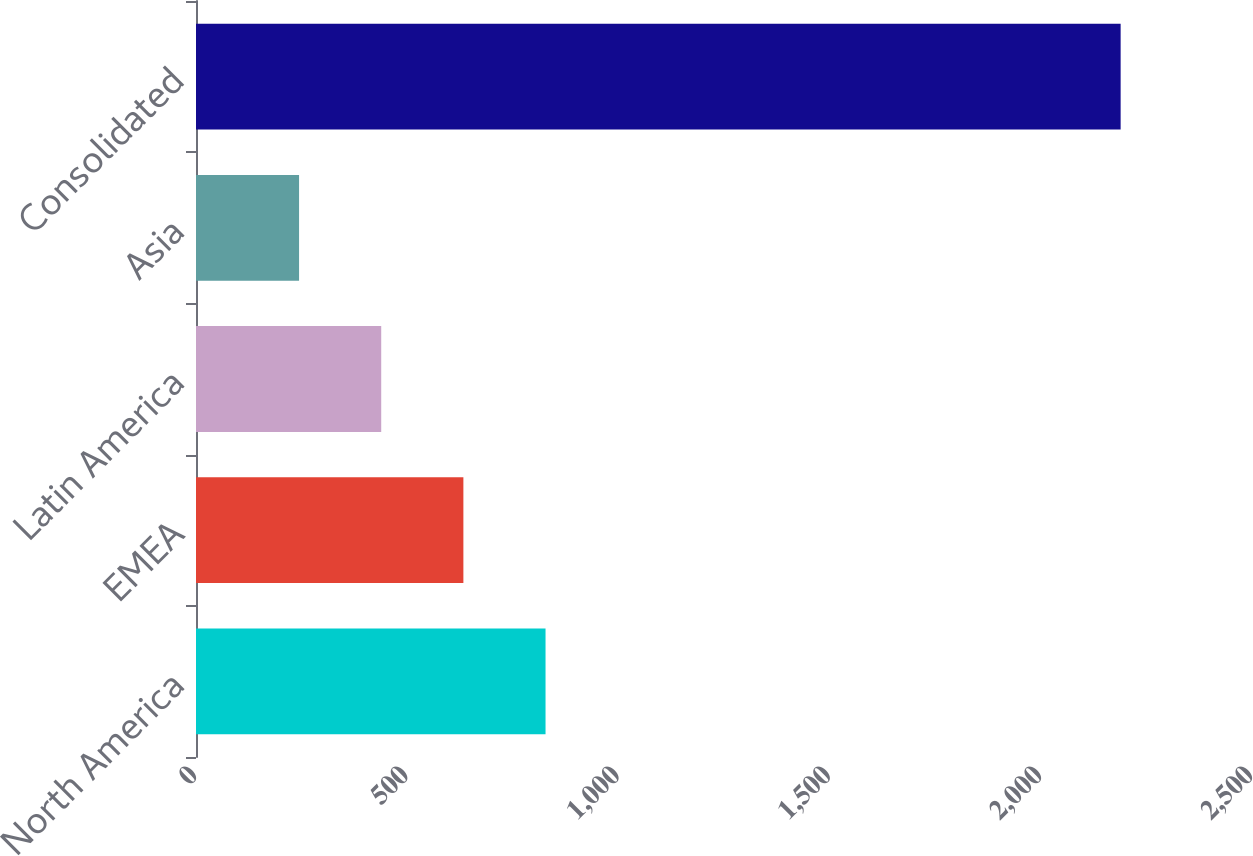Convert chart to OTSL. <chart><loc_0><loc_0><loc_500><loc_500><bar_chart><fcel>North America<fcel>EMEA<fcel>Latin America<fcel>Asia<fcel>Consolidated<nl><fcel>827.5<fcel>633<fcel>438.5<fcel>244<fcel>2189<nl></chart> 